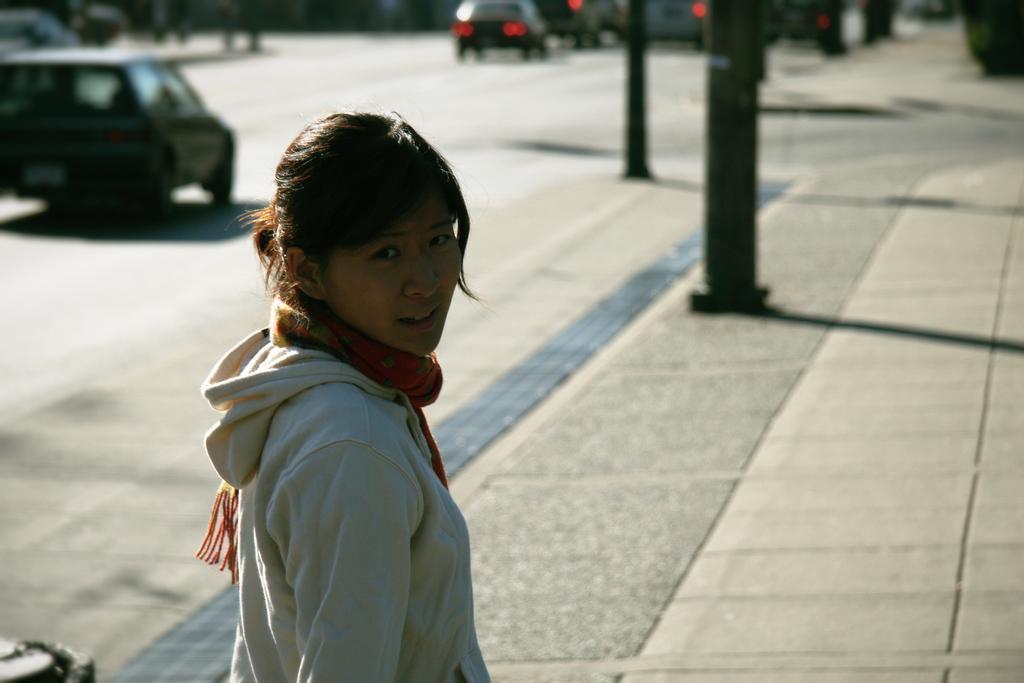Describe this image in one or two sentences. In this picture, we can see a lady highlighted, we can see the ground, vehicles, road, poles and, we can see the blurred background. 